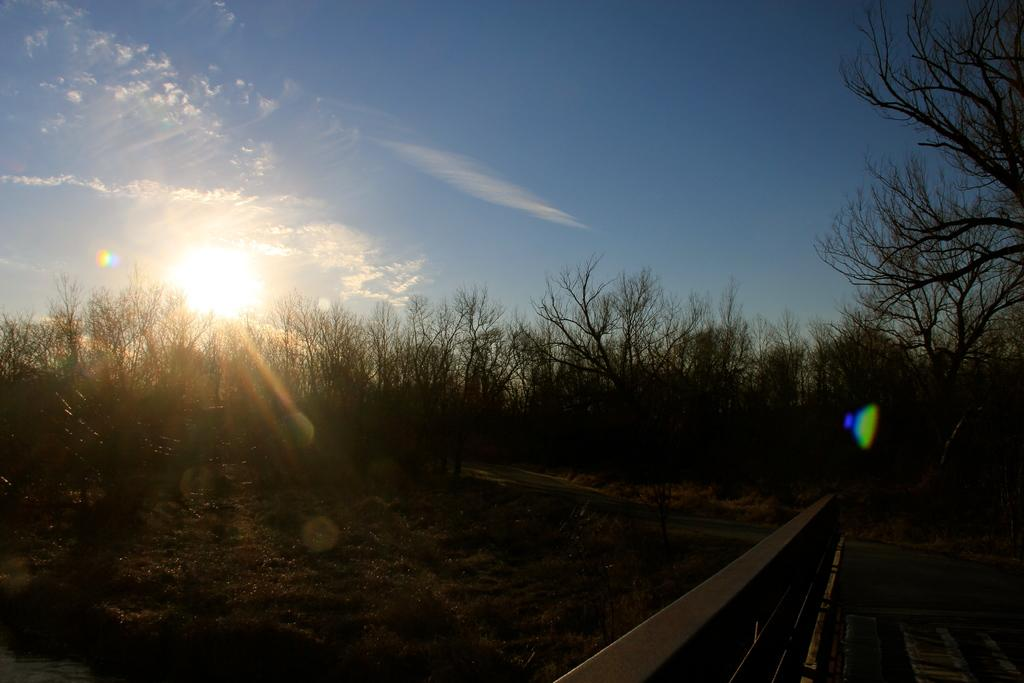What type of vegetation can be seen in the image? There are trees in the image. What is present at the bottom of the image? There is grass at the bottom of the image. What can be seen in the sky in the image? The sun is visible in the sky, and there are clouds as well. Can you describe any man-made structures in the image? There appears to be a bench in the image. What type of steel is used to construct the statement on the tray in the image? There is no steel, statement, or tray present in the image. 